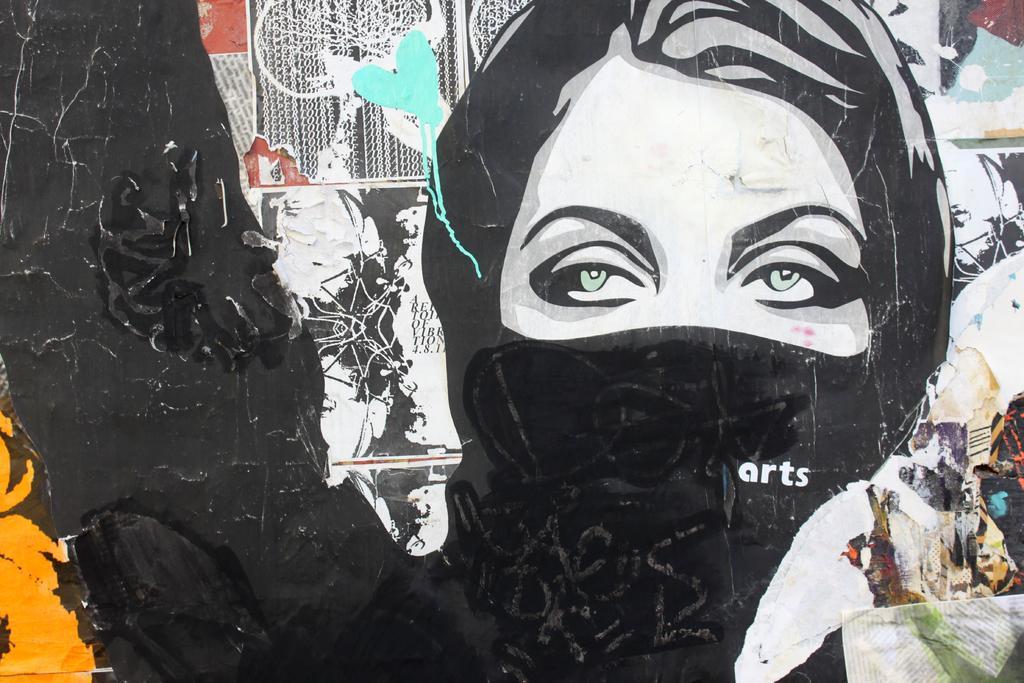In one or two sentences, can you explain what this image depicts? In this image we can see a wall painting. In the center of the image there is a lady wearing a mask and we can see some papers pasted on the wall. 